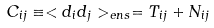<formula> <loc_0><loc_0><loc_500><loc_500>C _ { i j } \equiv < d _ { i } d _ { j } > _ { e n s } = T _ { i j } + N _ { i j }</formula> 